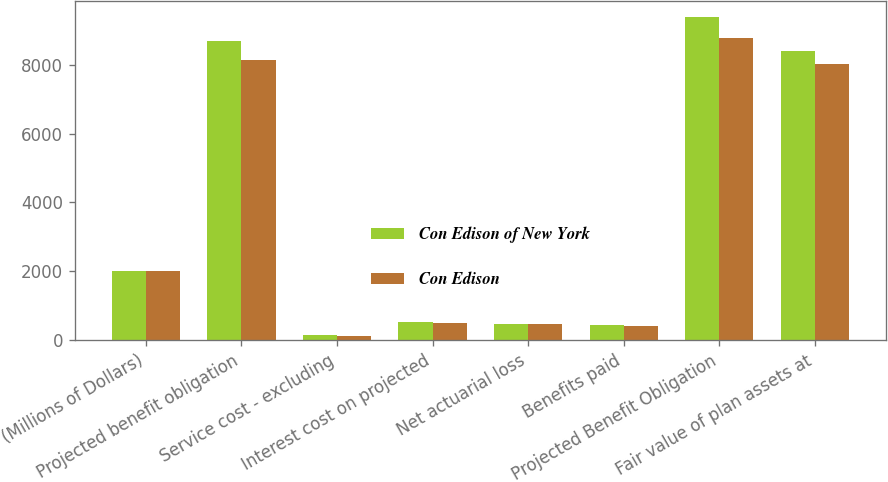Convert chart. <chart><loc_0><loc_0><loc_500><loc_500><stacked_bar_chart><ecel><fcel>(Millions of Dollars)<fcel>Projected benefit obligation<fcel>Service cost - excluding<fcel>Interest cost on projected<fcel>Net actuarial loss<fcel>Benefits paid<fcel>Projected Benefit Obligation<fcel>Fair value of plan assets at<nl><fcel>Con Edison of New York<fcel>2008<fcel>8696<fcel>137<fcel>515<fcel>468<fcel>433<fcel>9383<fcel>8400<nl><fcel>Con Edison<fcel>2008<fcel>8137<fcel>128<fcel>482<fcel>449<fcel>403<fcel>8793<fcel>8025<nl></chart> 